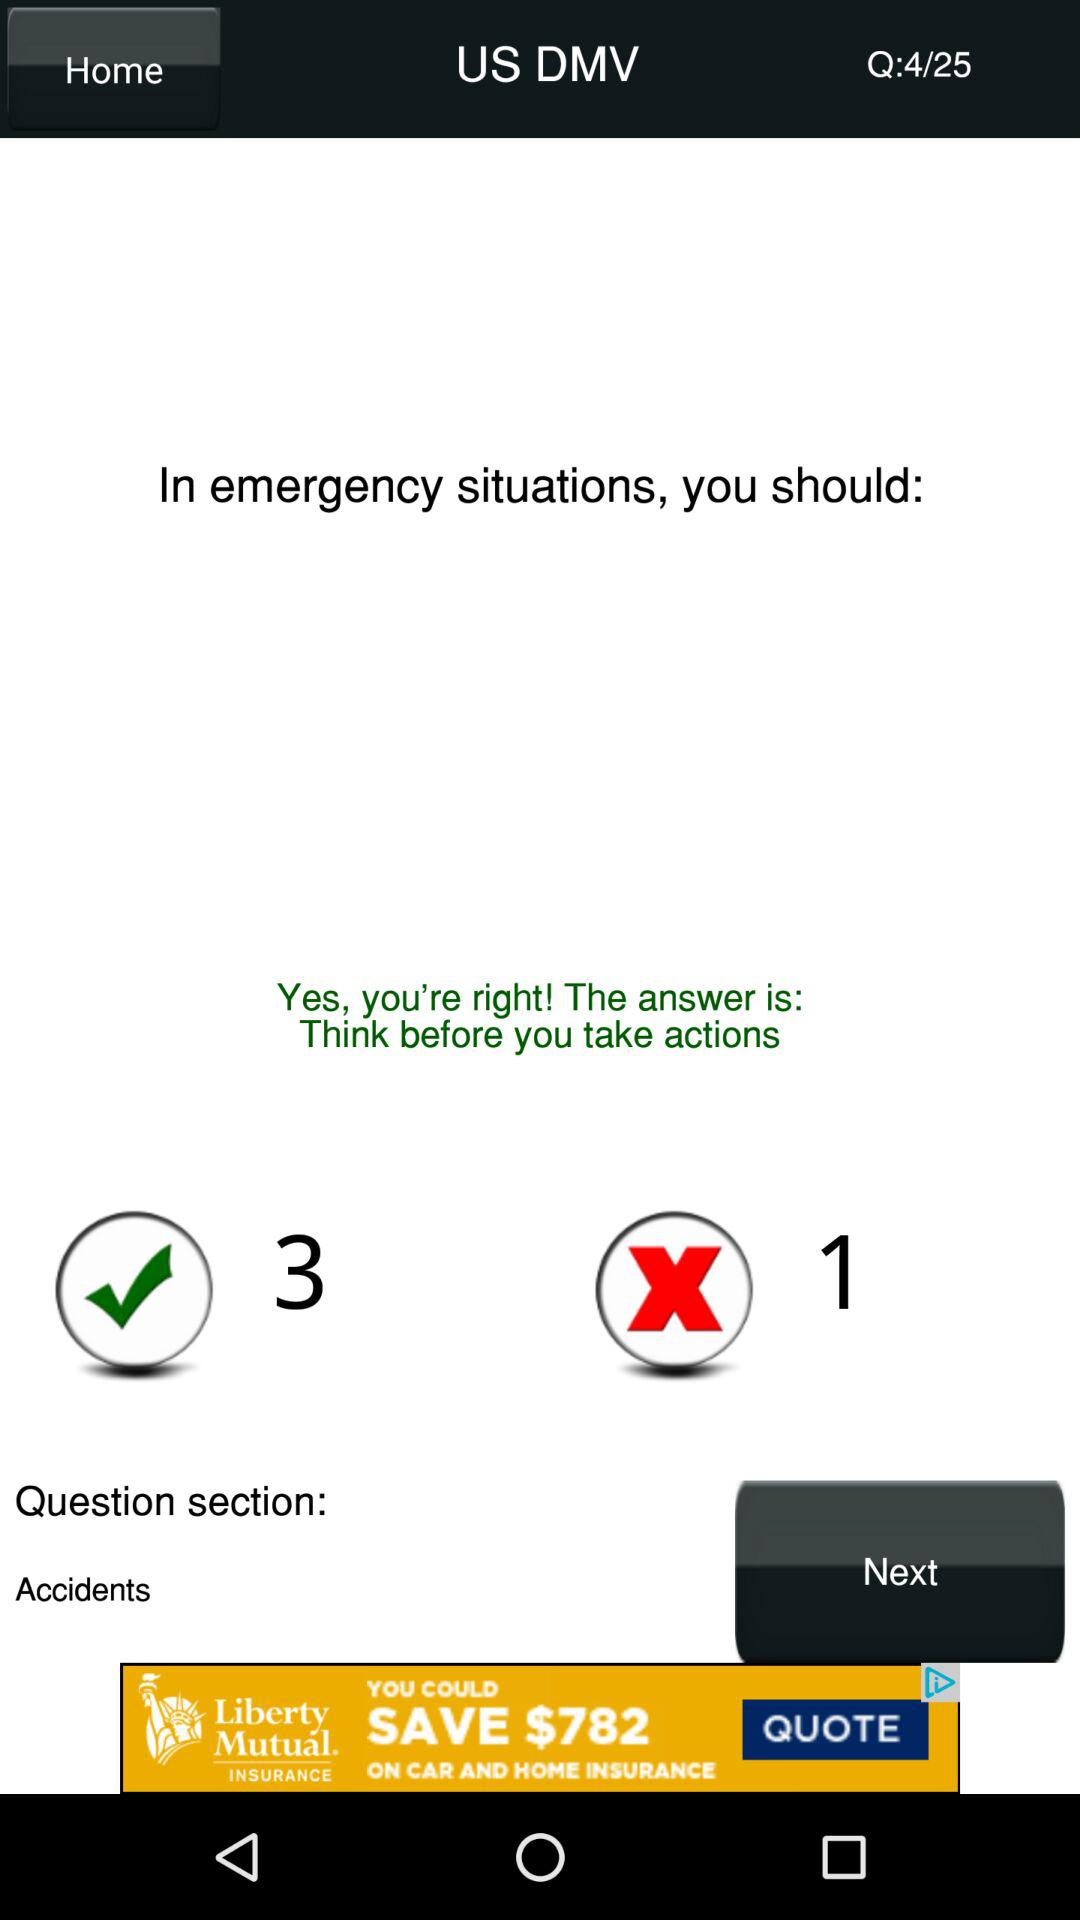What is the total number of questions displayed on the screen? The total number of questions is 25. 